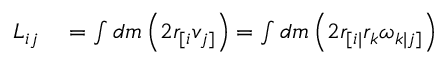Convert formula to latex. <formula><loc_0><loc_0><loc_500><loc_500>\begin{array} { r l } { L _ { i j } } & = \int d m \left ( 2 r _ { [ i } v _ { j ] } \right ) = \int d m \left ( 2 r _ { [ i | } r _ { k } \omega _ { k | j ] } \right ) } \end{array}</formula> 